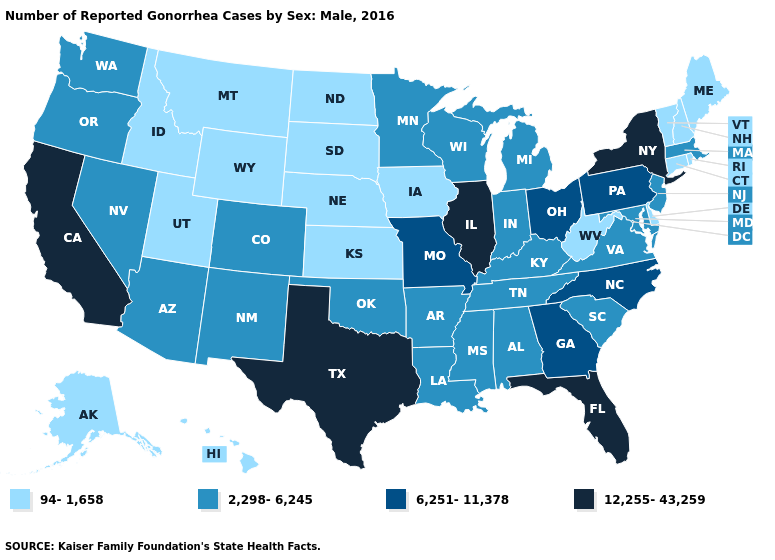What is the lowest value in the USA?
Answer briefly. 94-1,658. What is the highest value in states that border Washington?
Be succinct. 2,298-6,245. Which states have the lowest value in the USA?
Keep it brief. Alaska, Connecticut, Delaware, Hawaii, Idaho, Iowa, Kansas, Maine, Montana, Nebraska, New Hampshire, North Dakota, Rhode Island, South Dakota, Utah, Vermont, West Virginia, Wyoming. How many symbols are there in the legend?
Concise answer only. 4. Among the states that border Florida , which have the lowest value?
Answer briefly. Alabama. How many symbols are there in the legend?
Be succinct. 4. Does the first symbol in the legend represent the smallest category?
Quick response, please. Yes. Name the states that have a value in the range 2,298-6,245?
Quick response, please. Alabama, Arizona, Arkansas, Colorado, Indiana, Kentucky, Louisiana, Maryland, Massachusetts, Michigan, Minnesota, Mississippi, Nevada, New Jersey, New Mexico, Oklahoma, Oregon, South Carolina, Tennessee, Virginia, Washington, Wisconsin. What is the value of Delaware?
Keep it brief. 94-1,658. Does New Hampshire have the lowest value in the USA?
Keep it brief. Yes. What is the value of Connecticut?
Answer briefly. 94-1,658. Does Iowa have the highest value in the USA?
Be succinct. No. What is the value of Alaska?
Be succinct. 94-1,658. 